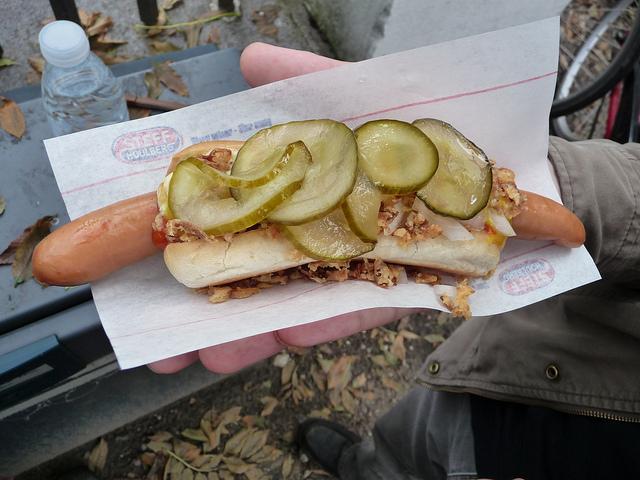What is she drinking?
Give a very brief answer. Water. What is wrapped around these hot dogs?
Concise answer only. Pickles. Which hand holds the sandwich?
Keep it brief. Right. What is the green vegetable on top of the hot dog called?
Quick response, please. Pickles. How long is the hot dog?
Short answer required. Footlong. 